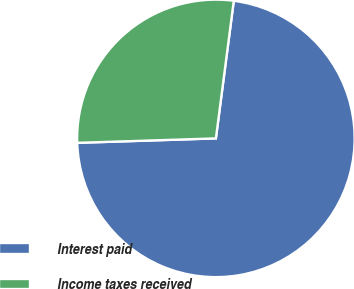Convert chart to OTSL. <chart><loc_0><loc_0><loc_500><loc_500><pie_chart><fcel>Interest paid<fcel>Income taxes received<nl><fcel>72.43%<fcel>27.57%<nl></chart> 